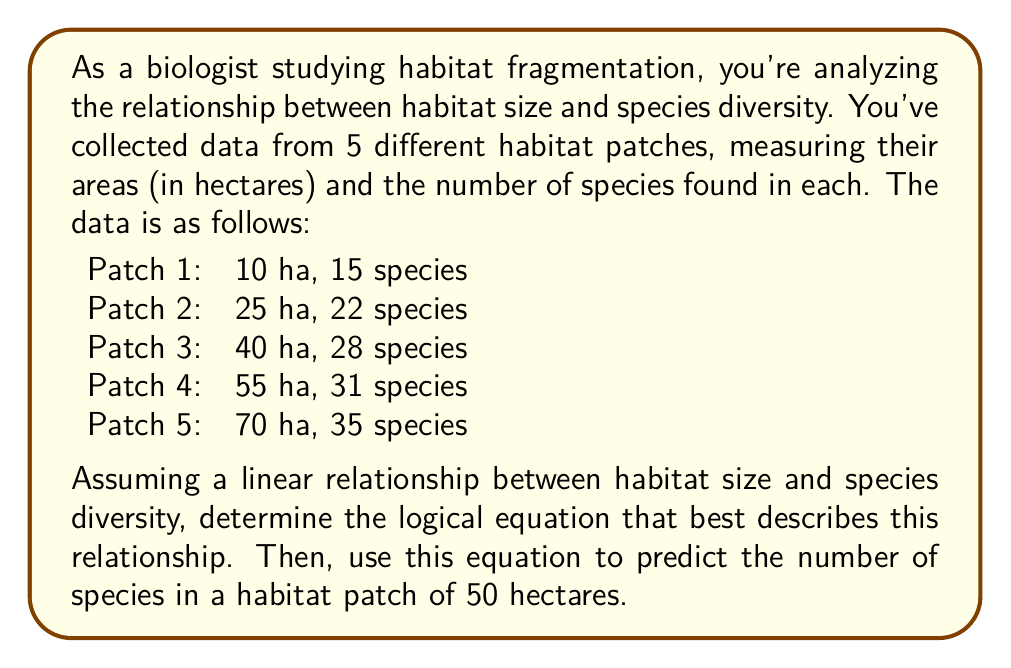Give your solution to this math problem. To determine the logical relationship between habitat size and species diversity, we'll use linear regression. The general form of a linear equation is:

$$ y = mx + b $$

Where $y$ is the dependent variable (species diversity), $x$ is the independent variable (habitat size), $m$ is the slope, and $b$ is the y-intercept.

1. Calculate the slope ($m$):
   $$ m = \frac{\sum_{i=1}^{n} (x_i - \bar{x})(y_i - \bar{y})}{\sum_{i=1}^{n} (x_i - \bar{x})^2} $$

   Where $\bar{x}$ is the mean of x values and $\bar{y}$ is the mean of y values.

   $\bar{x} = \frac{10 + 25 + 40 + 55 + 70}{5} = 40$
   $\bar{y} = \frac{15 + 22 + 28 + 31 + 35}{5} = 26.2$

   Calculating the numerator and denominator:
   $$ \sum_{i=1}^{n} (x_i - \bar{x})(y_i - \bar{y}) = 1180 $$
   $$ \sum_{i=1}^{n} (x_i - \bar{x})^2 = 3400 $$

   $$ m = \frac{1180}{3400} = 0.3471 $$

2. Calculate the y-intercept ($b$):
   $$ b = \bar{y} - m\bar{x} $$
   $$ b = 26.2 - (0.3471 \times 40) = 12.316 $$

3. The linear equation describing the relationship is:
   $$ y = 0.3471x + 12.316 $$

4. To predict the number of species in a 50-hectare patch:
   $$ y = 0.3471 \times 50 + 12.316 = 29.671 $$

Rounding to the nearest whole number, as we can't have fractional species, the prediction is 30 species.
Answer: The logical equation describing the relationship between habitat size ($x$) and species diversity ($y$) is:

$$ y = 0.3471x + 12.316 $$

For a habitat patch of 50 hectares, the predicted number of species is 30. 